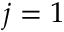<formula> <loc_0><loc_0><loc_500><loc_500>j = 1</formula> 